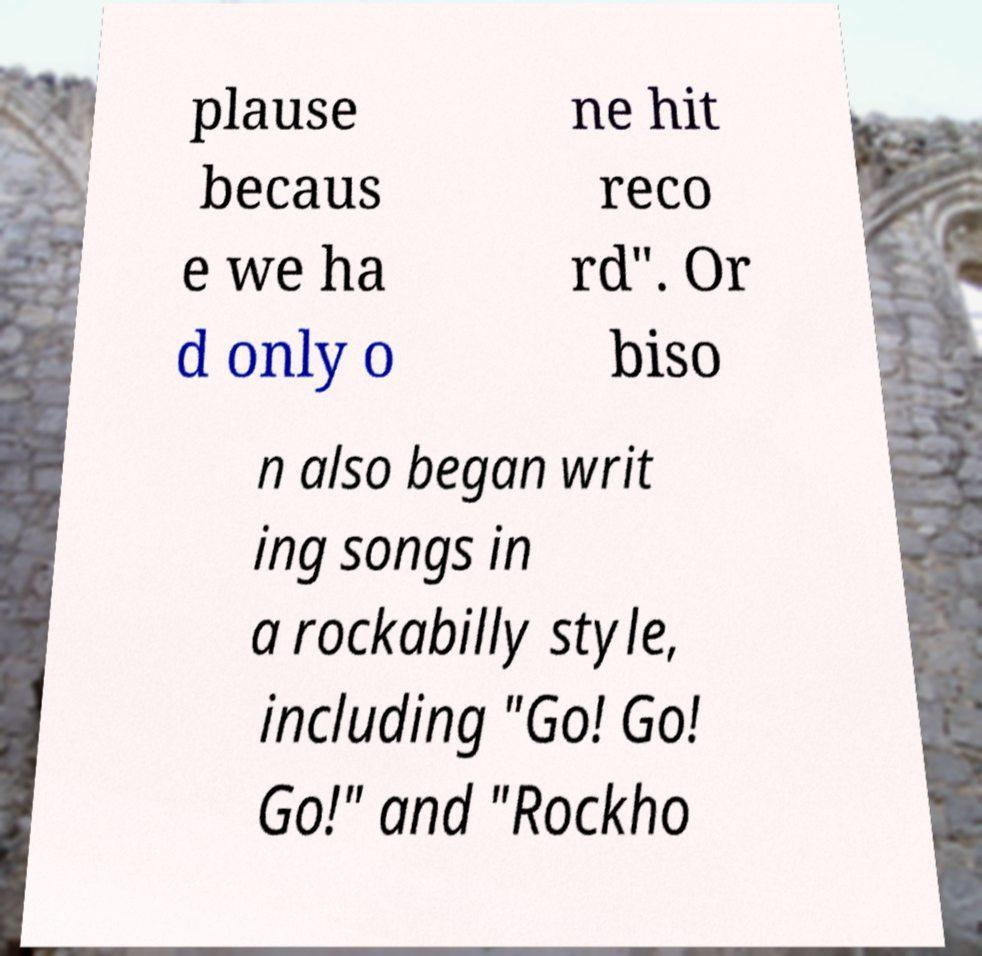Please read and relay the text visible in this image. What does it say? plause becaus e we ha d only o ne hit reco rd". Or biso n also began writ ing songs in a rockabilly style, including "Go! Go! Go!" and "Rockho 